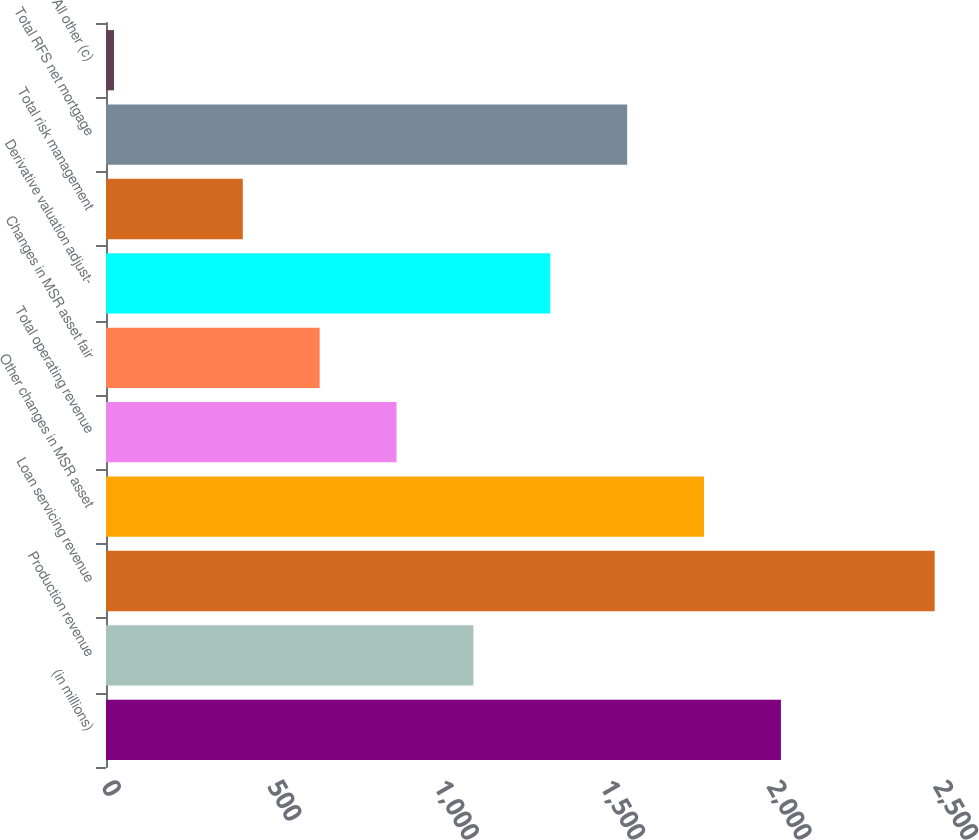<chart> <loc_0><loc_0><loc_500><loc_500><bar_chart><fcel>(in millions)<fcel>Production revenue<fcel>Loan servicing revenue<fcel>Other changes in MSR asset<fcel>Total operating revenue<fcel>Changes in MSR asset fair<fcel>Derivative valuation adjust-<fcel>Total risk management<fcel>Total RFS net mortgage<fcel>All other (c)<nl><fcel>2028<fcel>1104<fcel>2490<fcel>1797<fcel>873<fcel>642<fcel>1335<fcel>411<fcel>1566<fcel>24<nl></chart> 